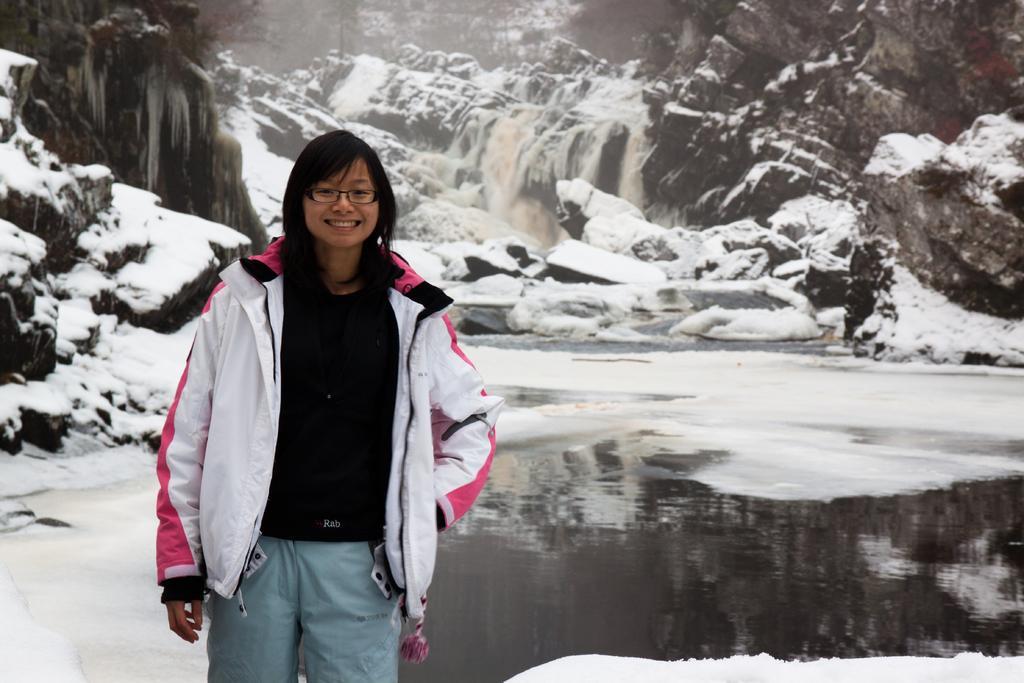Can you describe this image briefly? In this image there is a lady standing with a smile on her face, behind her there is some water on the surface. In the background there is a snow on the mountains and waterfall. 